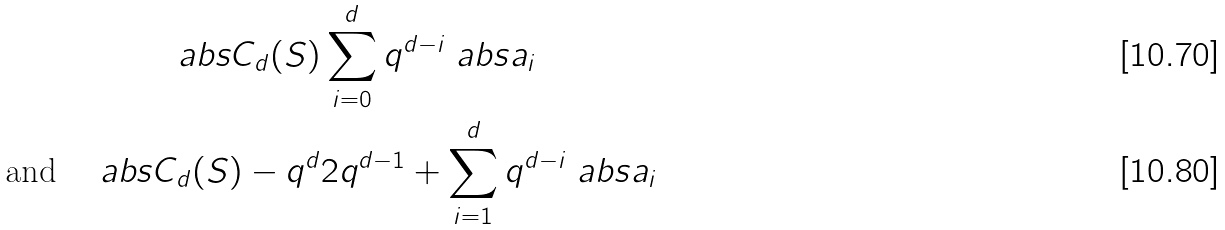Convert formula to latex. <formula><loc_0><loc_0><loc_500><loc_500>\ a b s { C _ { d } ( S ) } & \sum _ { i = 0 } ^ { d } q ^ { d - i } \ a b s { a _ { i } } \\ \text {and} \quad \ a b s { C _ { d } ( S ) - q ^ { d } } & 2 q ^ { d - 1 } + \sum _ { i = 1 } ^ { d } q ^ { d - i } \ a b s { a _ { i } }</formula> 